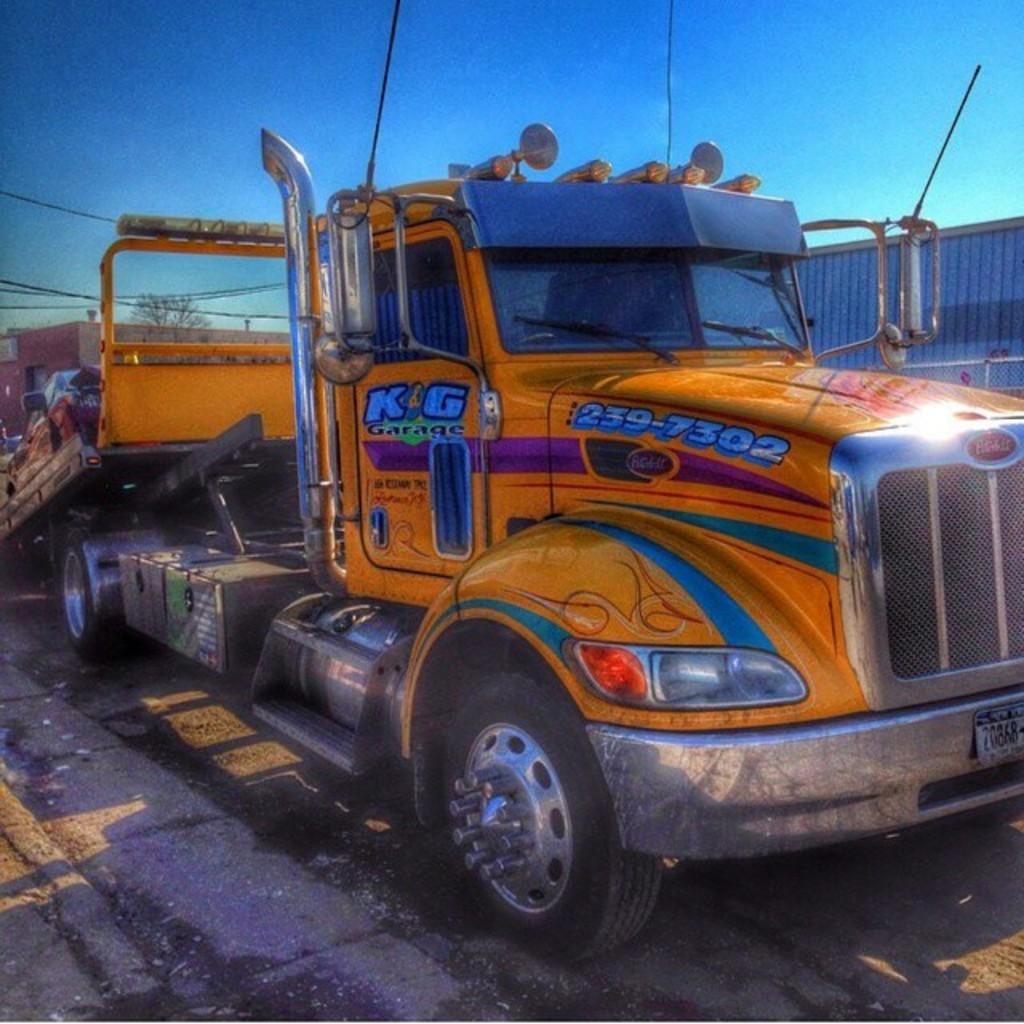How would you summarize this image in a sentence or two? This image is taken outdoors. At the top of the image there is the sky. At the bottom of the image there is a road. In the background there is a tree and there are a few wires. In the middle of the image there is a truck parked on the road. 